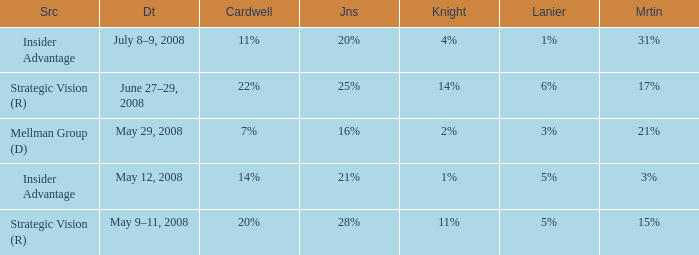What martin has a lanier of 6%? 17%. 